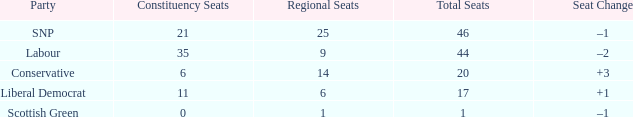What is the full number of Total Seats with a constituency seat number bigger than 0 with the Liberal Democrat party, and the Regional seat number is smaller than 6? None. 